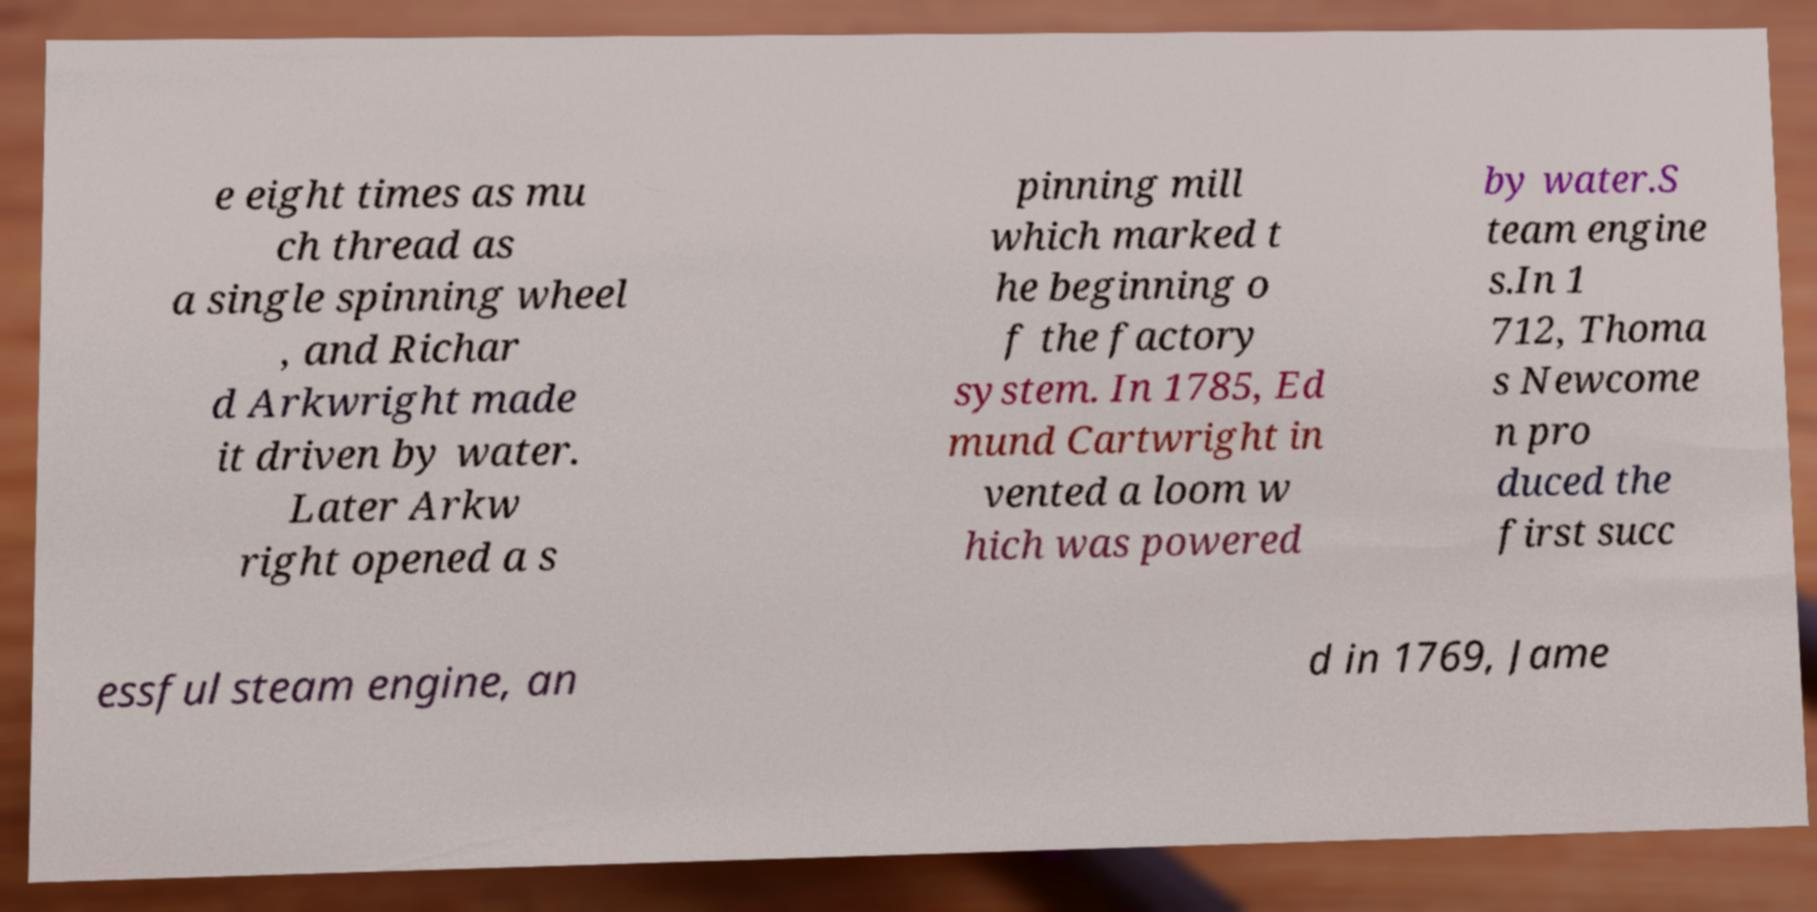Can you accurately transcribe the text from the provided image for me? e eight times as mu ch thread as a single spinning wheel , and Richar d Arkwright made it driven by water. Later Arkw right opened a s pinning mill which marked t he beginning o f the factory system. In 1785, Ed mund Cartwright in vented a loom w hich was powered by water.S team engine s.In 1 712, Thoma s Newcome n pro duced the first succ essful steam engine, an d in 1769, Jame 